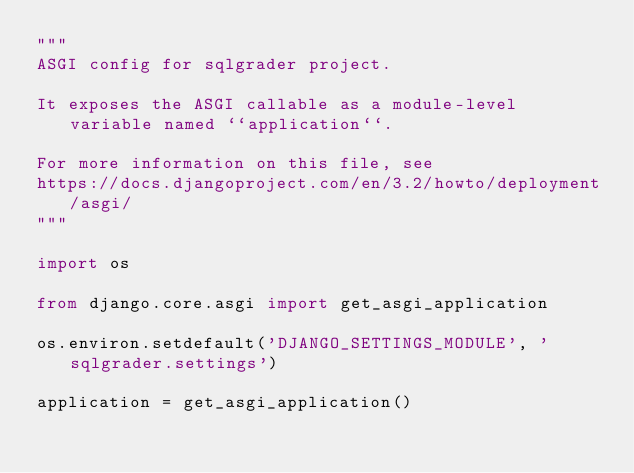Convert code to text. <code><loc_0><loc_0><loc_500><loc_500><_Python_>"""
ASGI config for sqlgrader project.

It exposes the ASGI callable as a module-level variable named ``application``.

For more information on this file, see
https://docs.djangoproject.com/en/3.2/howto/deployment/asgi/
"""

import os

from django.core.asgi import get_asgi_application

os.environ.setdefault('DJANGO_SETTINGS_MODULE', 'sqlgrader.settings')

application = get_asgi_application()
</code> 